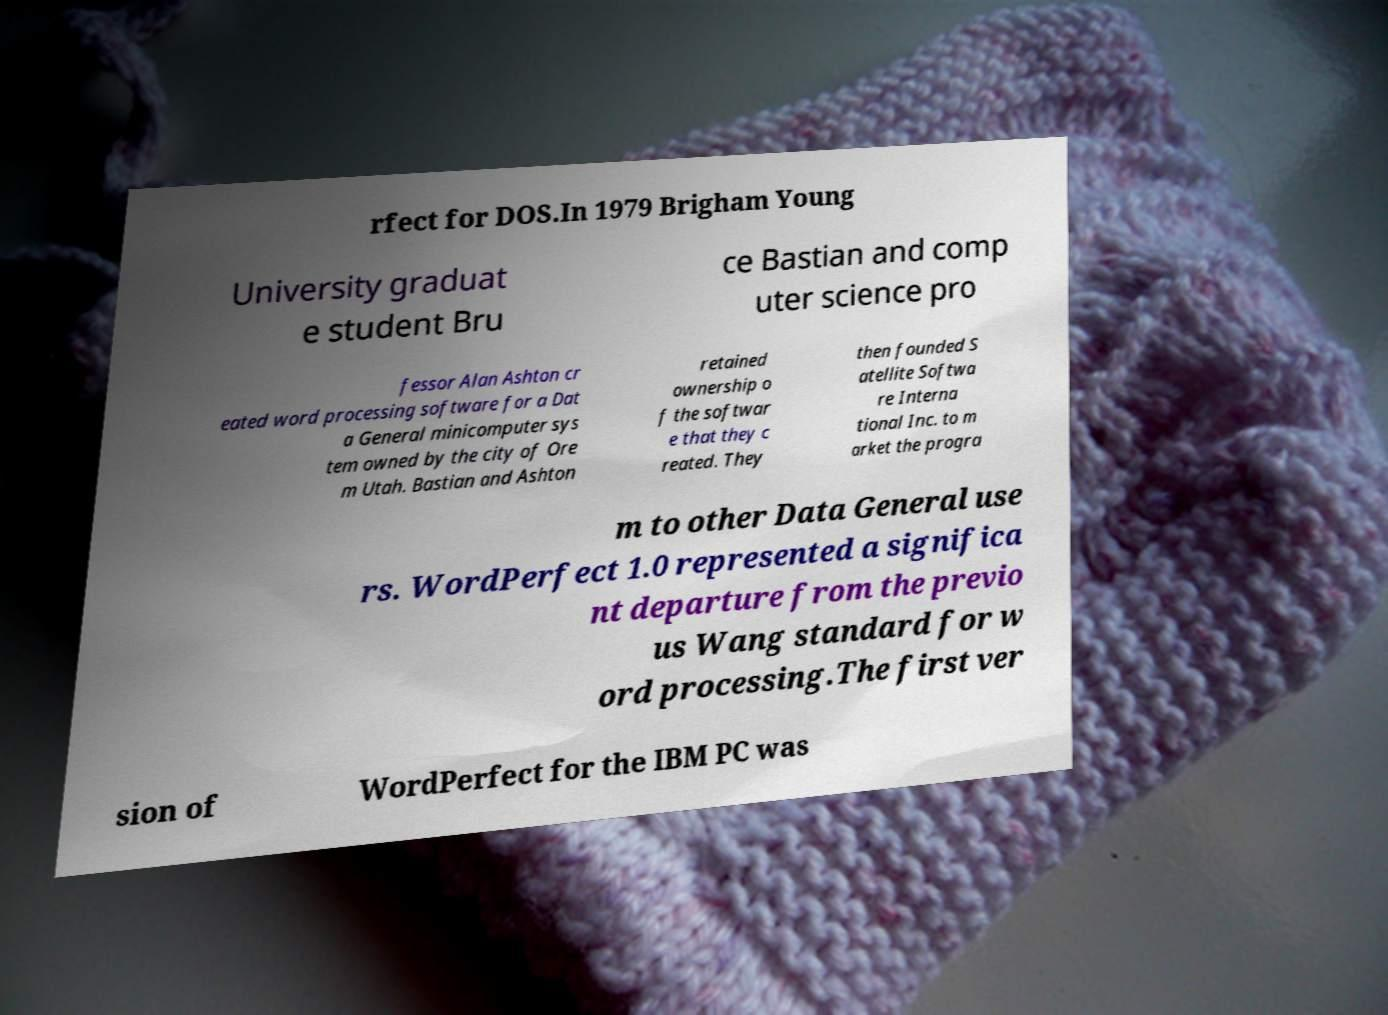Could you extract and type out the text from this image? rfect for DOS.In 1979 Brigham Young University graduat e student Bru ce Bastian and comp uter science pro fessor Alan Ashton cr eated word processing software for a Dat a General minicomputer sys tem owned by the city of Ore m Utah. Bastian and Ashton retained ownership o f the softwar e that they c reated. They then founded S atellite Softwa re Interna tional Inc. to m arket the progra m to other Data General use rs. WordPerfect 1.0 represented a significa nt departure from the previo us Wang standard for w ord processing.The first ver sion of WordPerfect for the IBM PC was 